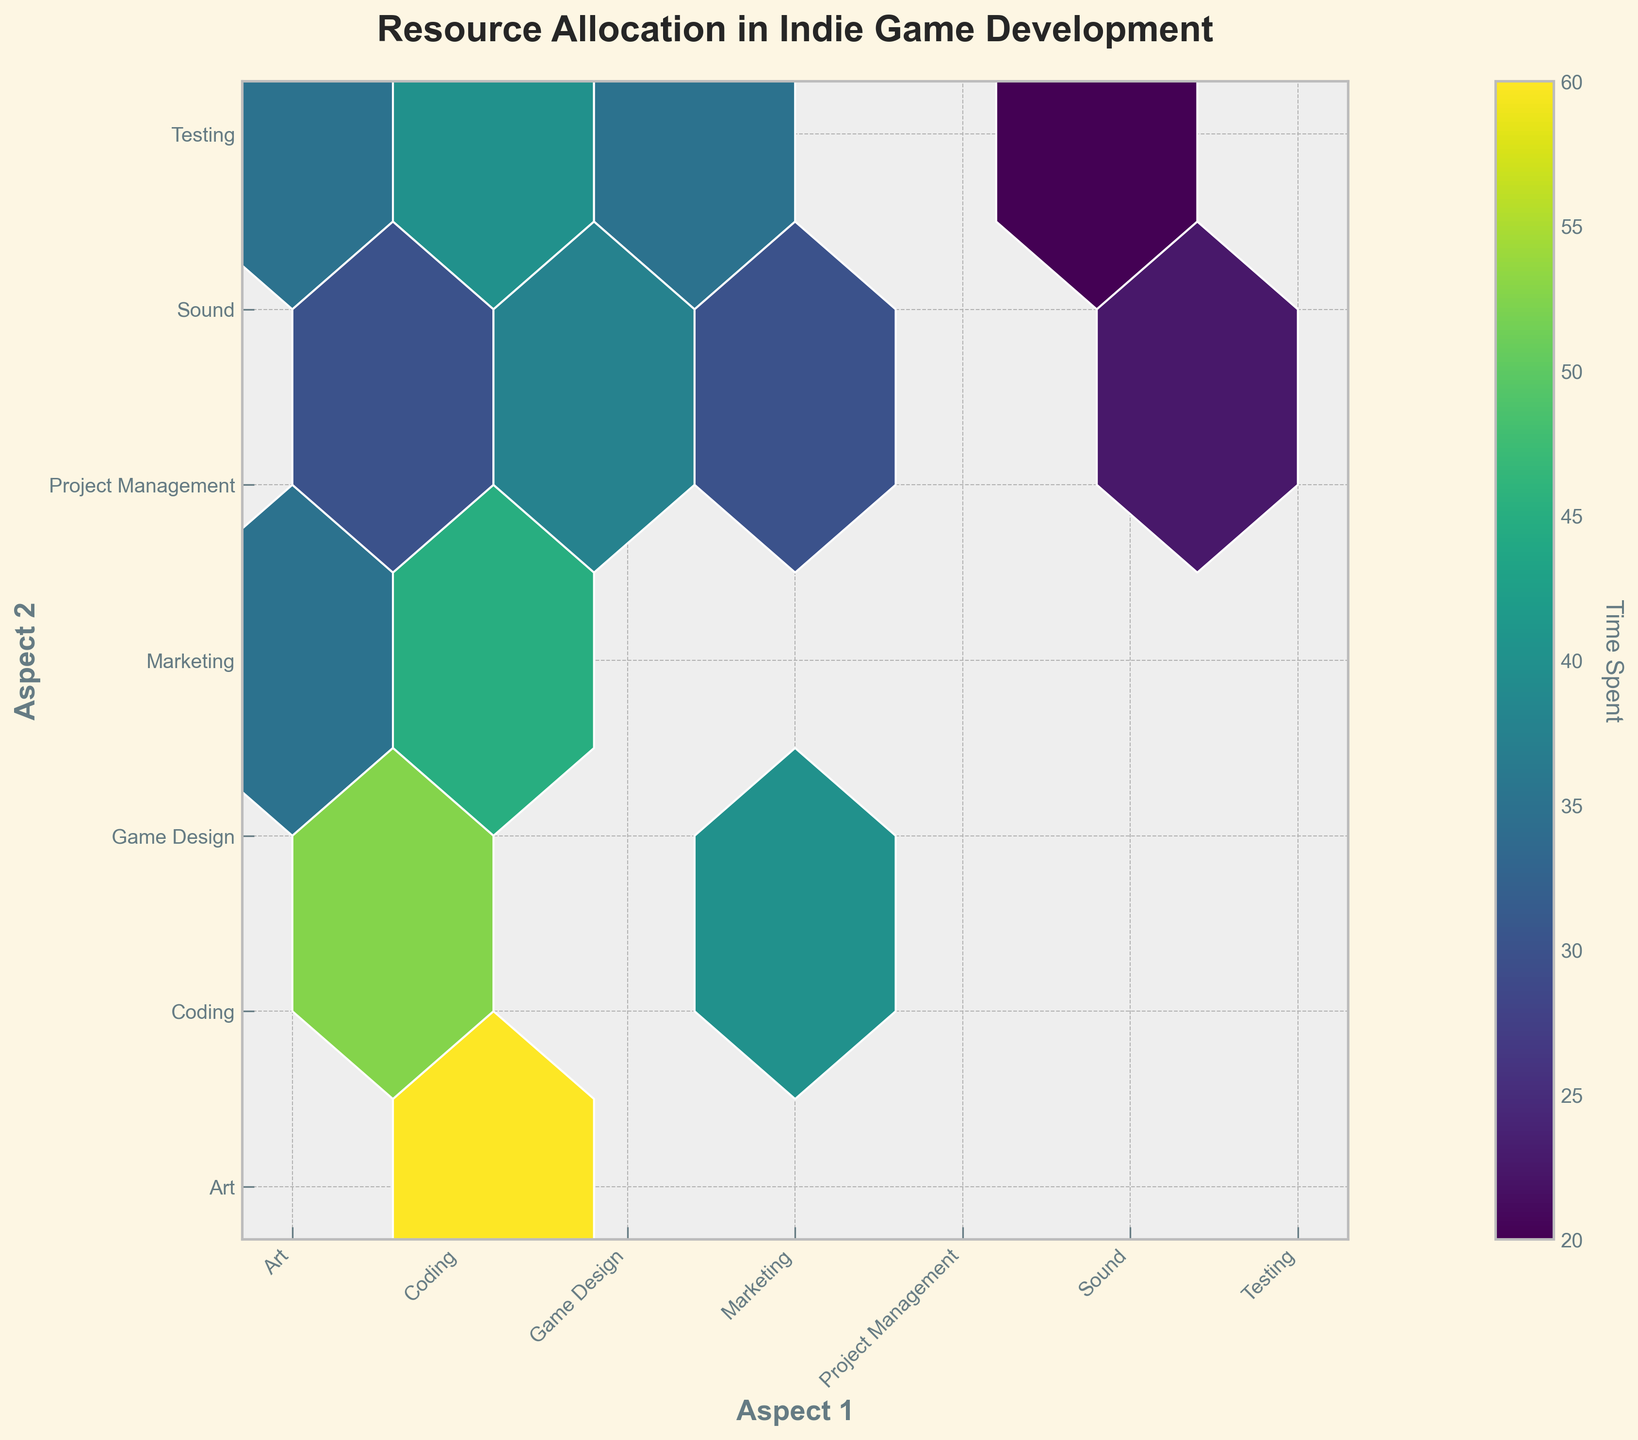What's the title of the plot? The title is located at the top of the figure and is usually in bold or larger font size. In this case, you can find the title directly above the hexbin plot.
Answer: Resource Allocation in Indie Game Development What aspects are compared on the x-axis and y-axis in the figure? The x-axis and y-axis labels represent the different aspects of game development being compared. The labels are displayed at the bottom and left side of the figure respectively.
Answer: Aspect 1 and Aspect 2 Which two aspects of indie game development are allocated the most time together? The color intensity in the hexbin plot indicates the amount of time spent. The hexbin with the highest intensity (darkest color) represents the highest time allocation.
Answer: Coding and Art Is more time spent on Coding and Marketing or on Art and Game Design? Identify the hexbin corresponding to Coding and Marketing, and the hexbin corresponding to Art and Game Design. Compare the color intensities of these two hexagons.
Answer: More time on Art and Game Design Are there any aspects that have equal time allocated to Testing and Marketing? Locate the hexagons corresponding to Testing and Marketing, and any other aspect paired with Testing or Marketing. Check if there are any hexagons with the same color intensity.
Answer: No What's the average time spent on Coding with all other aspects? Sum the times spent on Coding with other aspects (Marketing, Art, Sound, Game Design, Testing, Project Management) and divide by the number of these aspects.
Answer: \( (45 + 60 + 30 + 55 + 40 + 35) / 6 = 44.17 \) Which aspect has the least time allocation with Project Management? In the hexbin plot, look for the hexagons intersecting with Project Management. Identify the one with the lowest color intensity.
Answer: Sound How does the time allocated to Art compare to the time allocated to Marketing with Project Management? Compare the color intensity of the hexbin for Art and Project Management with the hexbin for Marketing and Project Management.
Answer: Time spent on Marketing is higher What's the difference in time spent on Sound and Testing vs. Sound and Coding? Identify the color intensity for Sound and Testing, and for Sound and Coding. Calculate the difference in their times.
Answer: \(30 - 20 = 10\) How many hexagons in the plot involve the aspect of Testing? Count the hexagons in both the row and column corresponding to Testing.
Answer: 6 